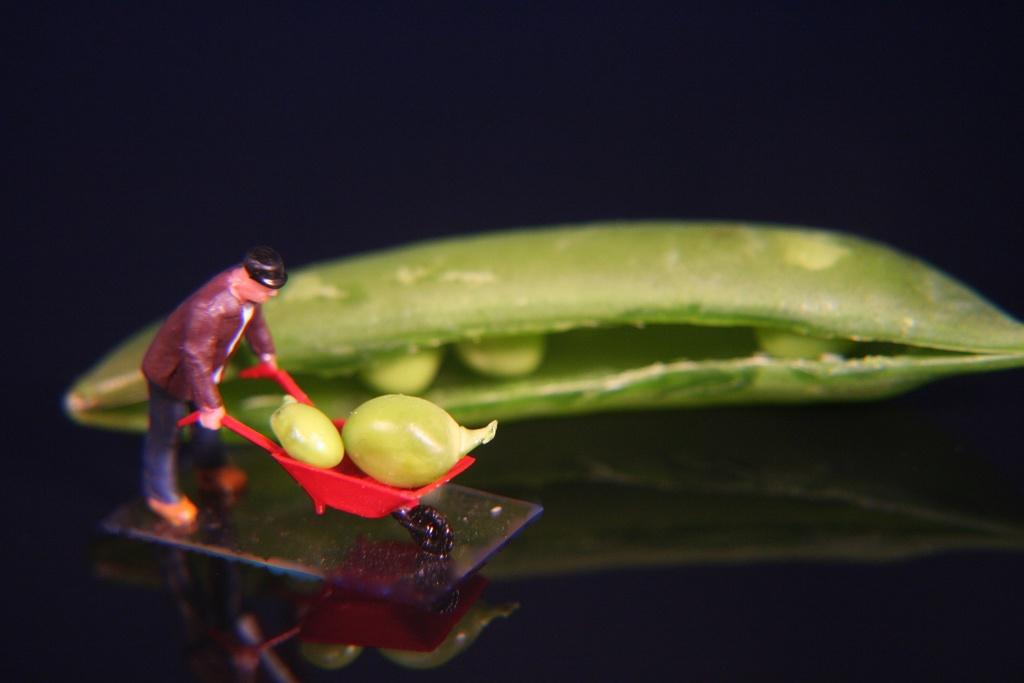What type of food item is present in the image? There is a vegetable in the image. What is the person in the image doing? The person is holding a cart vehicle in the image. What can be found inside the cart vehicle? The cart vehicle contains some objects. What color is the background of the image? The background of the image is black. What type of comb is being used to untangle the wire in the image? There is no comb or wire present in the image. How does the mass of the vegetable affect the person's ability to hold the cart vehicle? The mass of the vegetable does not affect the person's ability to hold the cart vehicle, as the vegetable is not interacting with the cart vehicle in the image. 